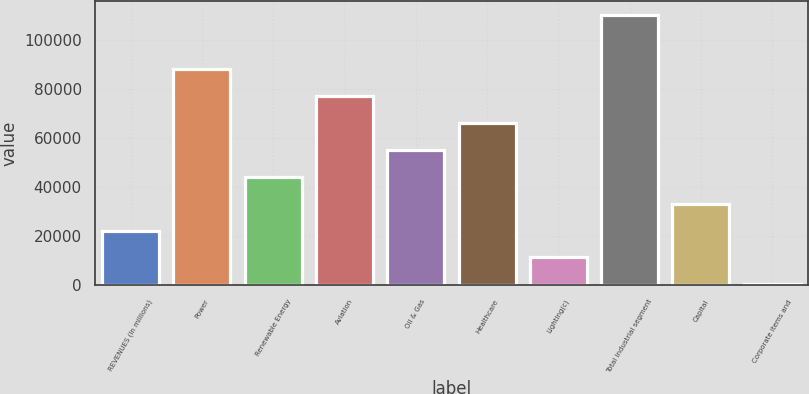Convert chart. <chart><loc_0><loc_0><loc_500><loc_500><bar_chart><fcel>REVENUES (In millions)<fcel>Power<fcel>Renewable Energy<fcel>Aviation<fcel>Oil & Gas<fcel>Healthcare<fcel>Lighting(c)<fcel>Total industrial segment<fcel>Capital<fcel>Corporate items and<nl><fcel>22368.6<fcel>88424.4<fcel>44387.2<fcel>77415.1<fcel>55396.5<fcel>66405.8<fcel>11359.3<fcel>110443<fcel>33377.9<fcel>350<nl></chart> 